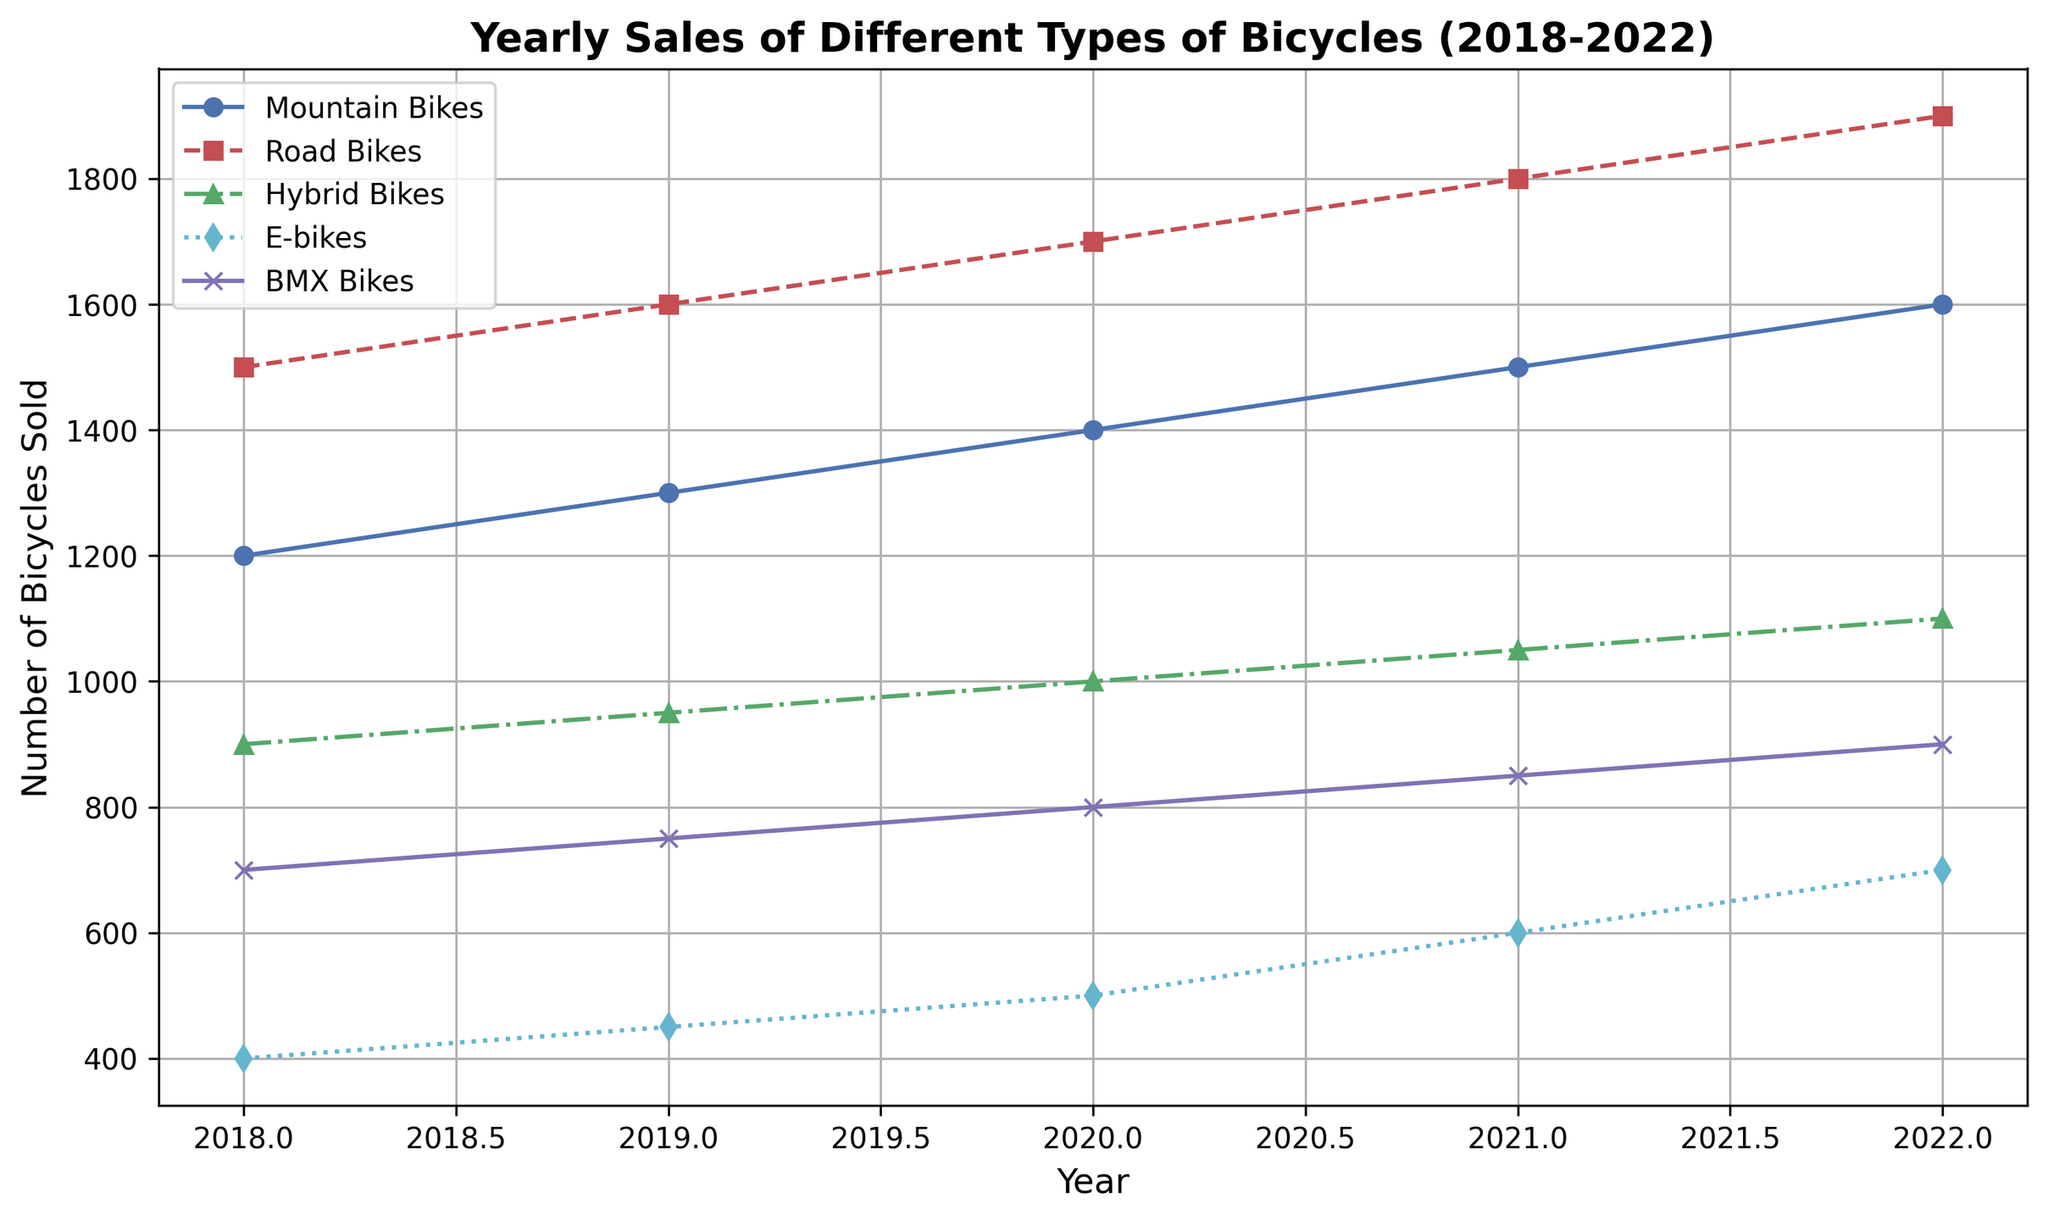What's the trend in sales for Road Bikes from 2018 to 2022? Look at the line representing Road Bikes (red line with square markers) and note its increase over the years. Sales go from 1500 in 2018 to 1900 in 2022, indicating an upward trend.
Answer: Increasing In which year did E-bikes experience the highest sales? Find the line representing E-bikes (cyan line with diamond markers) and compare the sales values each year. The highest point is in 2022 with 700 sales.
Answer: 2022 How much did sales of Mountain Bikes increase from 2018 to 2022? Look at the beginning and end points of the line for Mountain Bikes (blue line with circle markers) and subtract the earlier value from the later one: 1600 - 1200 = 400.
Answer: 400 Which type of bicycle had the least sales increase over the 5 years? Calculate the difference in sales from 2018 to 2022 for each type and compare.
- Mountain Bikes: 1600 - 1200 = 400
- Road Bikes: 1900 - 1500 = 400
- Hybrid Bikes: 1100 - 900 = 200 
- E-bikes: 700 - 400 = 300
- BMX Bikes: 900 - 700 = 200
Hybrid Bikes and BMX Bikes both increased by only 200 units, which is the least.
Answer: Hybrid Bikes and BMX Bikes Which type of bicycle had the highest sales in 2020? Look at the values for each bicycle type in 2020 and find the highest one. Road Bikes have the highest sales with 1700 units.
Answer: Road Bikes What is the total number of bicycles sold in 2019 across all types? Sum the sales for each type of bicycle in 2019: 1300 (Mountain Bikes) + 1600 (Road Bikes) + 950 (Hybrid Bikes) + 450 (E-bikes) + 750 (BMX Bikes) = 5050.
Answer: 5050 By how much did sales of E-bikes increase from 2020 to 2022? Look at the sales values for E-bikes in 2020 and 2022, then subtract the 2020 value from the 2022 value: 700 - 500 = 200.
Answer: 200 Which type of bicycle showed the most consistent year-over-year increase in sales from 2018 to 2022? Observe the trend lines for each type and determine which line has a steady, consistent increase year over year. The Road Bikes (red line) have the most consistent increase.
Answer: Road Bikes 